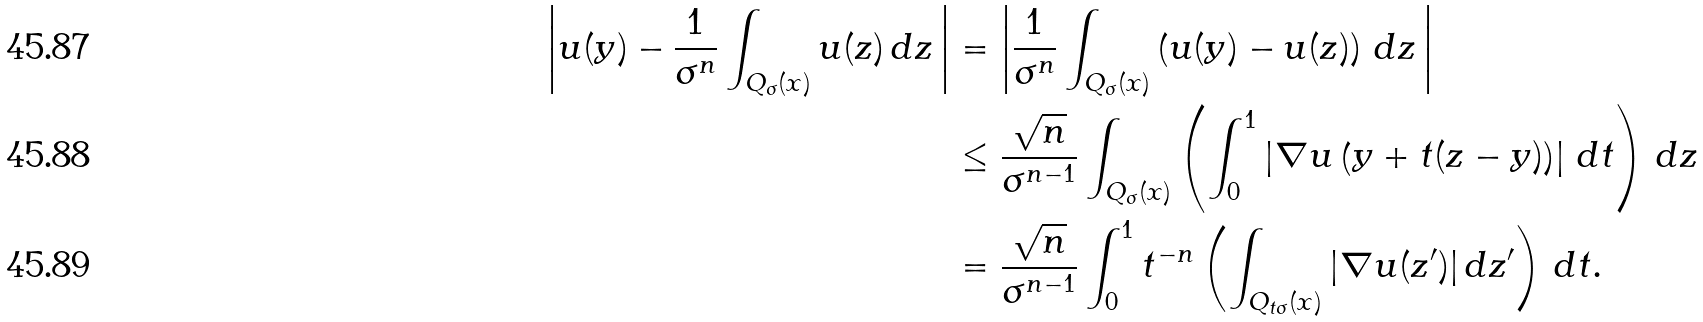Convert formula to latex. <formula><loc_0><loc_0><loc_500><loc_500>\left | u ( y ) - \frac { 1 } { \sigma ^ { n } } \int _ { Q _ { \sigma } ( x ) } u ( z ) \, d z \, \right | & = \left | \frac { 1 } { \sigma ^ { n } } \int _ { Q _ { \sigma } ( x ) } \left ( u ( y ) - u ( z ) \right ) \, d z \, \right | \\ & \leq \frac { \sqrt { n } } { \sigma ^ { n - 1 } } \int _ { Q _ { \sigma } ( x ) } \left ( \int _ { 0 } ^ { 1 } \left | \nabla u \left ( y + t ( z - y ) \right ) \right | \, d t \right ) \, d z \\ & = \frac { \sqrt { n } } { \sigma ^ { n - 1 } } \int _ { 0 } ^ { 1 } t ^ { - n } \left ( \int _ { Q _ { t \sigma } ( x ) } | \nabla u ( z ^ { \prime } ) | \, d z ^ { \prime } \right ) \, d t .</formula> 